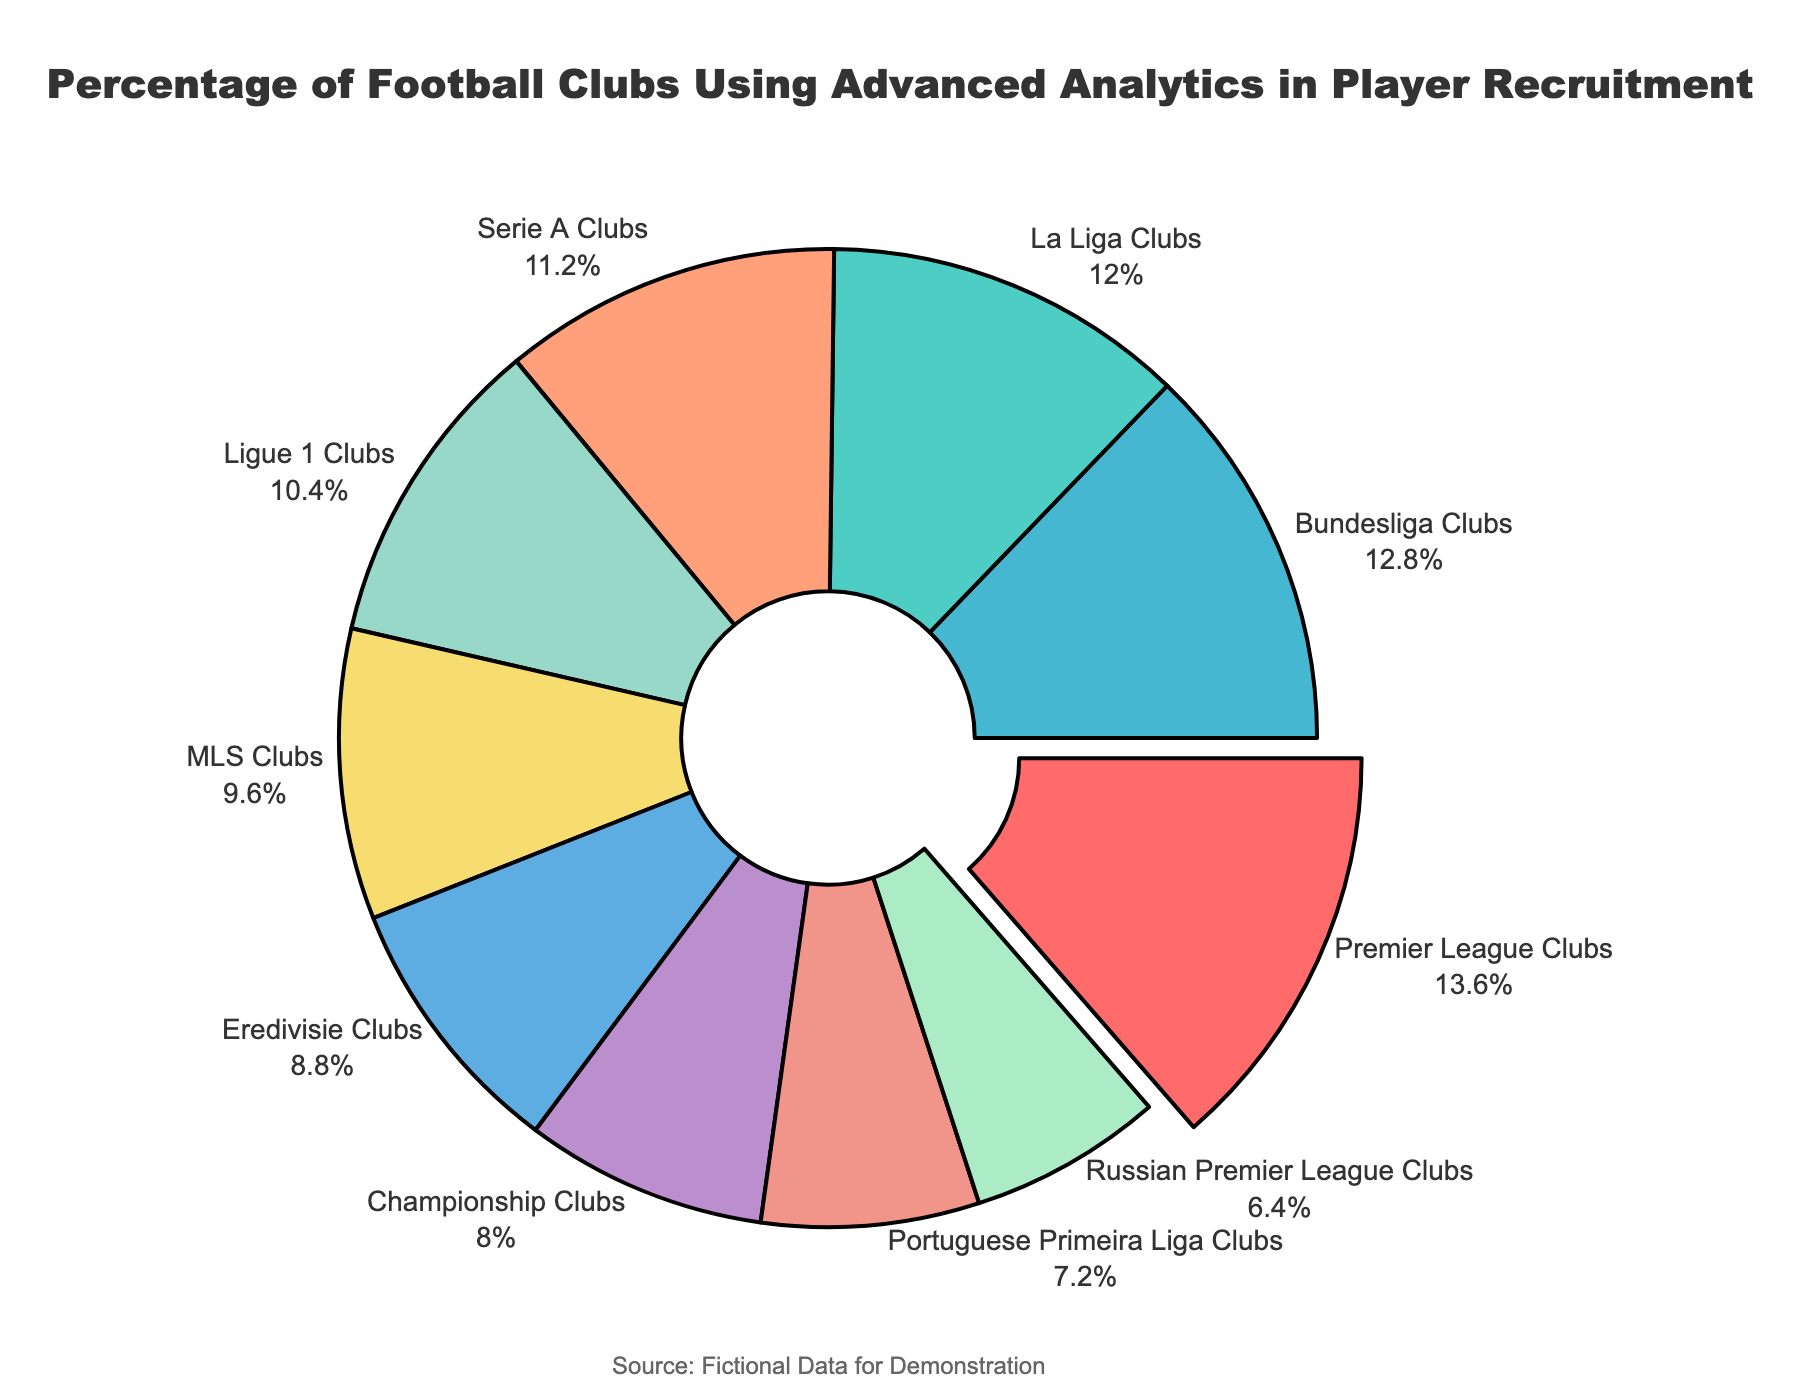Which league has the highest percentage of clubs using advanced analytics in player recruitment? The label showing the highest percentage is Premier League Clubs, which stands out from the rest.
Answer: Premier League Clubs What is the difference in the percentage of clubs using advanced analytics between the Premier League and the Russian Premier League? The Premier League has 85%, and the Russian Premier League has 40%. The difference is calculated as 85 - 40.
Answer: 45 Which leagues have a percentage of clubs using advanced analytics greater than 70%? Clubs meeting this criteria are Premier League (85%), La Liga (75%), and Bundesliga (80%).
Answer: Premier League, La Liga, Bundesliga What is the combined percentage of clubs using advanced analytics in Serie A, Ligue 1, and MLS? The percentages for Serie A, Ligue 1, and MLS are 70%, 65%, and 60% respectively. The combined percentage is 70 + 65 + 60.
Answer: 195 Which category is visually distinguished from the rest by being pulled out from the rest of the pie chart? The visual distinction by pulling out is given to the Premier League Clubs since it has the highest percentage.
Answer: Premier League Clubs What is the average percentage of clubs using advanced analytics in the top 5 leagues (Premier League, La Liga, Bundesliga, Serie A, and Ligue 1)? Adding up the top 5 leagues' percentages: 85% (Premier League) + 75% (La Liga) + 80% (Bundesliga) + 70% (Serie A) + 65% (Ligue 1) = 375%; then, dividing by 5 (the number of leagues): 375 / 5.
Answer: 75 Is the percentage of Championship clubs using advanced analytics in player recruitment more or less than half of the percentage for Premier League clubs? The Championship clubs' percentage is 50%, while the Premier League clubs' percentage is 85%. Comparing this: 50% is less than half of 85% (42.5%).
Answer: Less Which league has the closest percentage of clubs using analytics to MLS? MLS has 60%, and the closest percentage to that is Eredivisie Clubs with 55%.
Answer: Eredivisie Clubs Among the leagues below 70%, which one has the highest percentage of clubs using advanced analytics? Among those below 70% (Ligue 1, MLS, Championship, Eredivisie, Portuguese Primeira Liga, Russian Premier League), Ligue 1 has the highest at 65%.
Answer: Ligue 1 What is the sum of the percentages of all leagues using advanced analytics in player recruitment? Adding all the percentages: 85 (Premier League) + 75 (La Liga) + 80 (Bundesliga) + 70 (Serie A) + 65 (Ligue 1) + 60 (MLS) + 50 (Championship) + 55 (Eredivisie) + 45 (Portuguese Primeira Liga) + 40 (Russian Premier League) = 625.
Answer: 625 